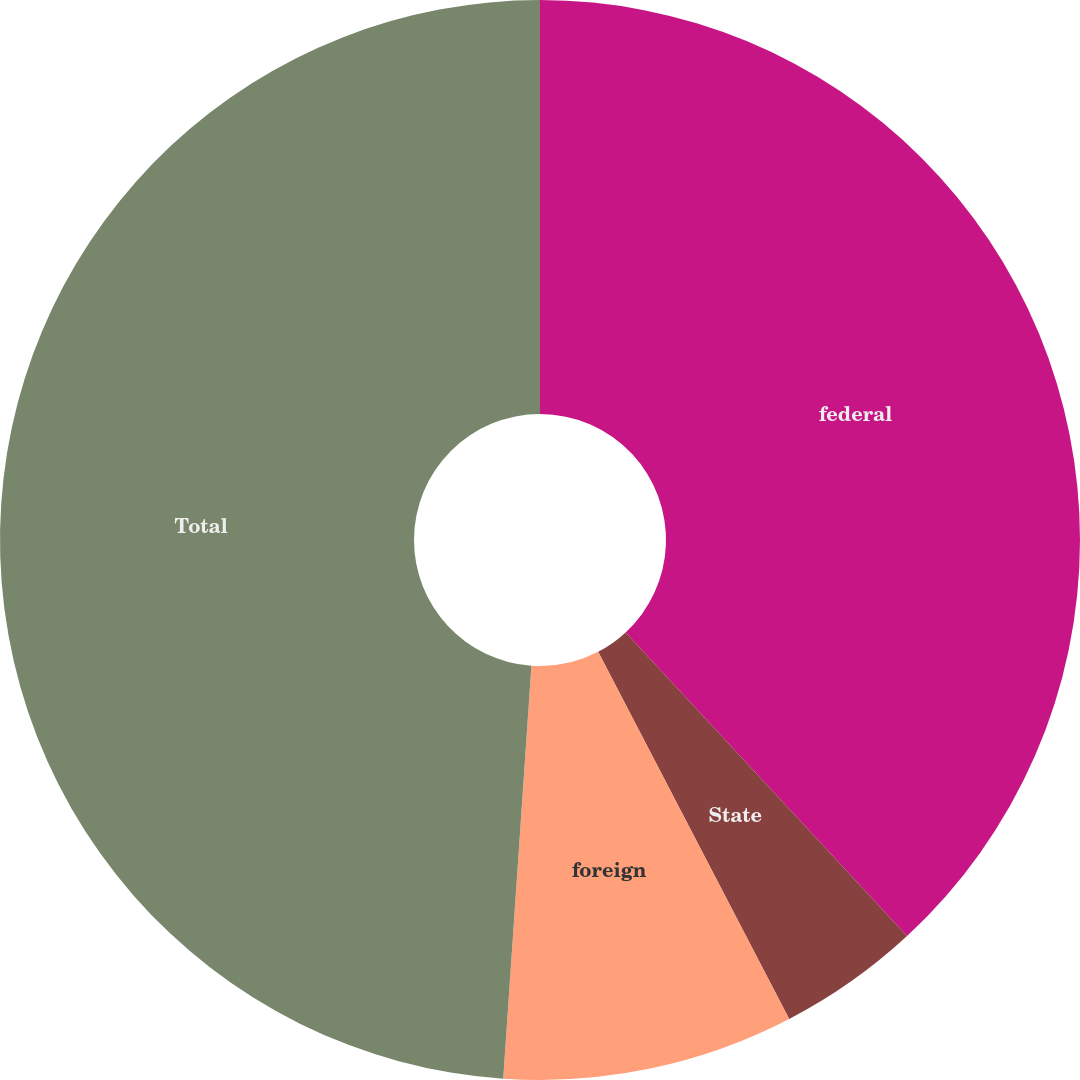<chart> <loc_0><loc_0><loc_500><loc_500><pie_chart><fcel>federal<fcel>State<fcel>foreign<fcel>Total<nl><fcel>38.11%<fcel>4.26%<fcel>8.72%<fcel>48.92%<nl></chart> 